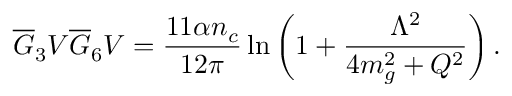<formula> <loc_0><loc_0><loc_500><loc_500>\overline { G } _ { 3 } V \overline { G } _ { 6 } V = { \frac { 1 1 \alpha n _ { c } } { 1 2 \pi } } \ln { \left ( 1 + { \frac { \Lambda ^ { 2 } } { 4 m _ { g } ^ { 2 } + Q ^ { 2 } } } \right ) } \, .</formula> 